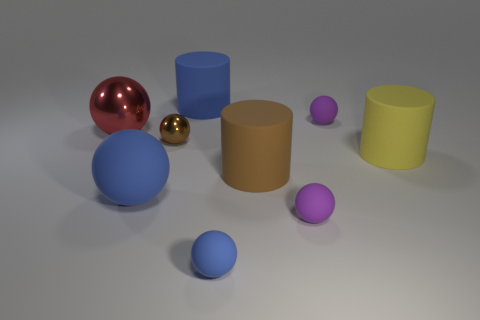What is the size of the other rubber sphere that is the same color as the large rubber ball?
Provide a succinct answer. Small. Is the number of purple balls less than the number of large brown matte cylinders?
Your response must be concise. No. Does the yellow thing have the same shape as the blue matte thing that is behind the big blue ball?
Give a very brief answer. Yes. What shape is the blue thing that is right of the brown ball and in front of the brown metallic object?
Give a very brief answer. Sphere. Are there an equal number of blue cylinders that are in front of the large brown cylinder and big yellow cylinders that are to the left of the small blue thing?
Your answer should be compact. Yes. There is a tiny purple rubber object behind the large yellow cylinder; is it the same shape as the yellow matte object?
Your answer should be compact. No. What number of green objects are cubes or tiny balls?
Make the answer very short. 0. What is the material of the large yellow object that is the same shape as the large brown thing?
Ensure brevity in your answer.  Rubber. What is the shape of the brown object that is on the left side of the small blue matte sphere?
Your answer should be very brief. Sphere. Are there any large blue objects that have the same material as the blue cylinder?
Your response must be concise. Yes. 